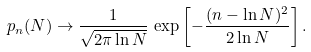Convert formula to latex. <formula><loc_0><loc_0><loc_500><loc_500>p _ { n } ( N ) \to \frac { 1 } { \sqrt { 2 \pi \ln N } } \, \exp \left [ - \frac { ( n - \ln N ) ^ { 2 } } { 2 \ln N } \right ] .</formula> 